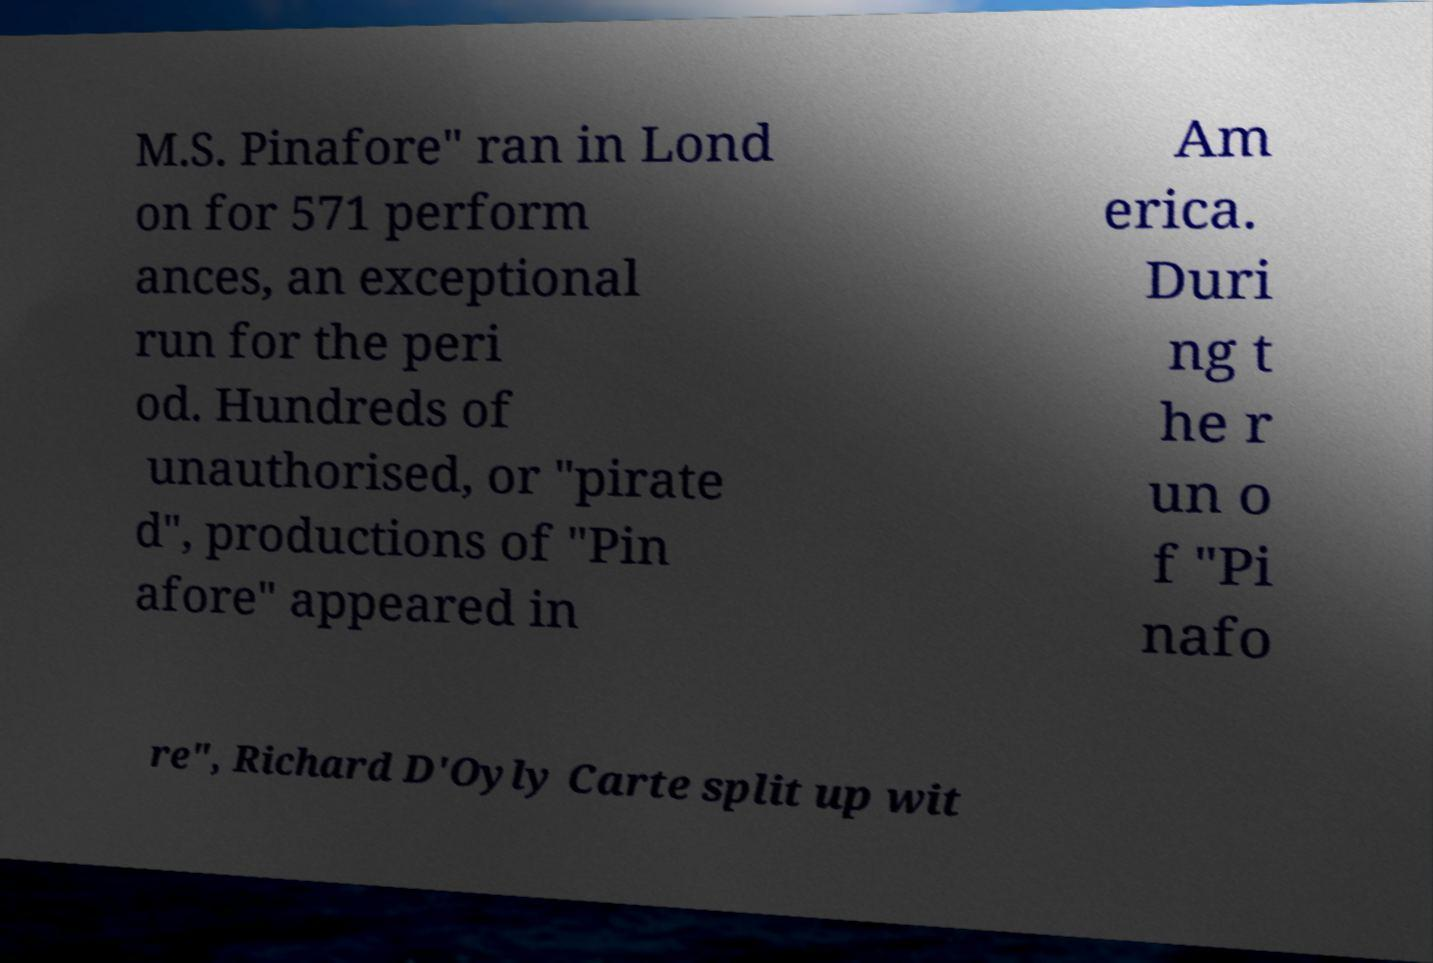I need the written content from this picture converted into text. Can you do that? M.S. Pinafore" ran in Lond on for 571 perform ances, an exceptional run for the peri od. Hundreds of unauthorised, or "pirate d", productions of "Pin afore" appeared in Am erica. Duri ng t he r un o f "Pi nafo re", Richard D'Oyly Carte split up wit 